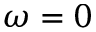<formula> <loc_0><loc_0><loc_500><loc_500>\omega = 0</formula> 